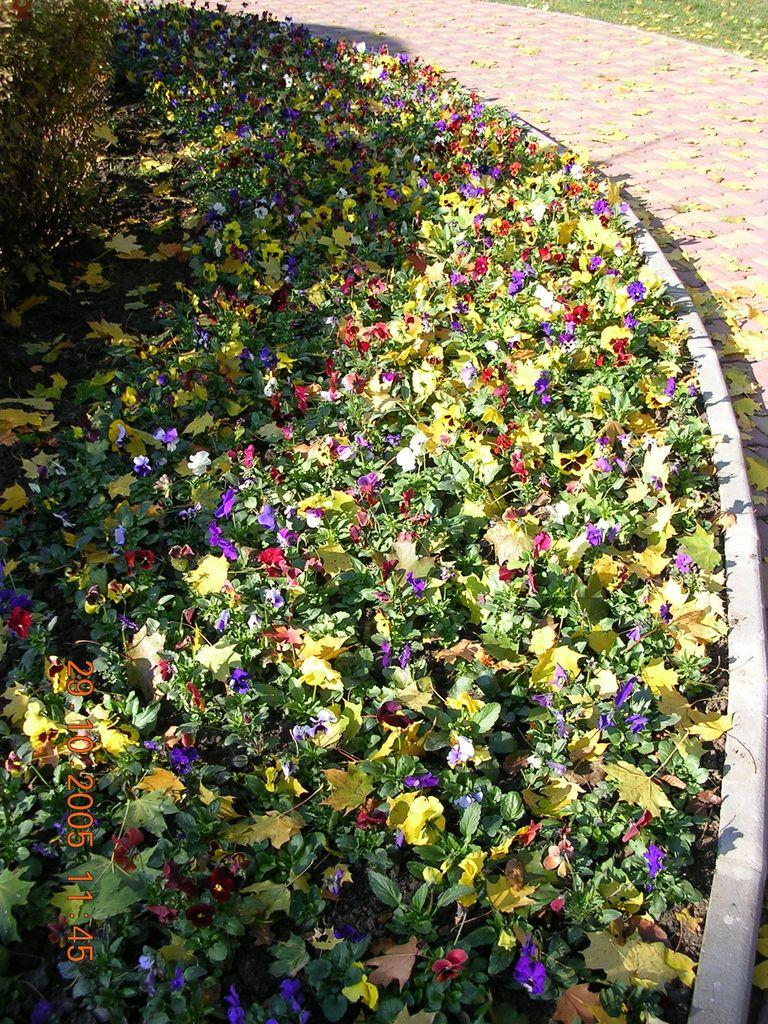What type of vegetation can be seen in the image? There are flowers on the plants in the image. What can be seen in the background of the image? There is a path visible in the image. What is present on the path in the image? Dry leaves are present on the path in the image. How does the crowd affect the profit in the image? There is no mention of a crowd or profit in the image, as it only features flowers on plants, a path, and dry leaves. 